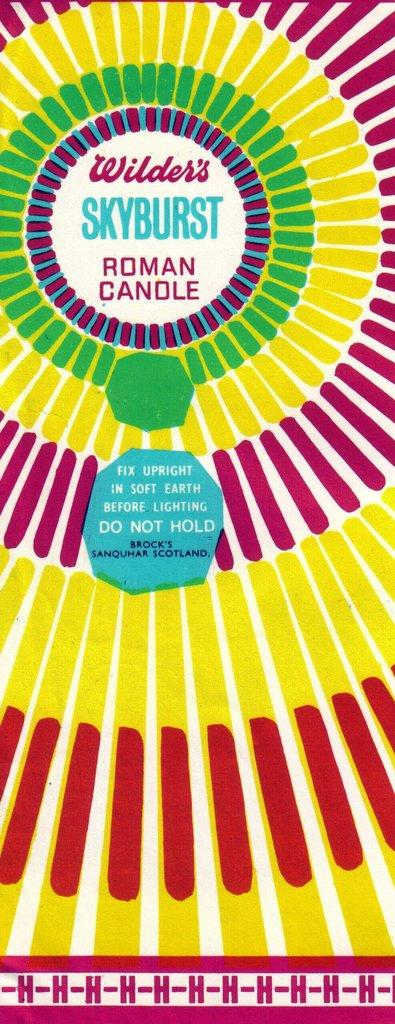<image>
Describe the image concisely. A roman candle package for Wilder's skyburst roman candle. 